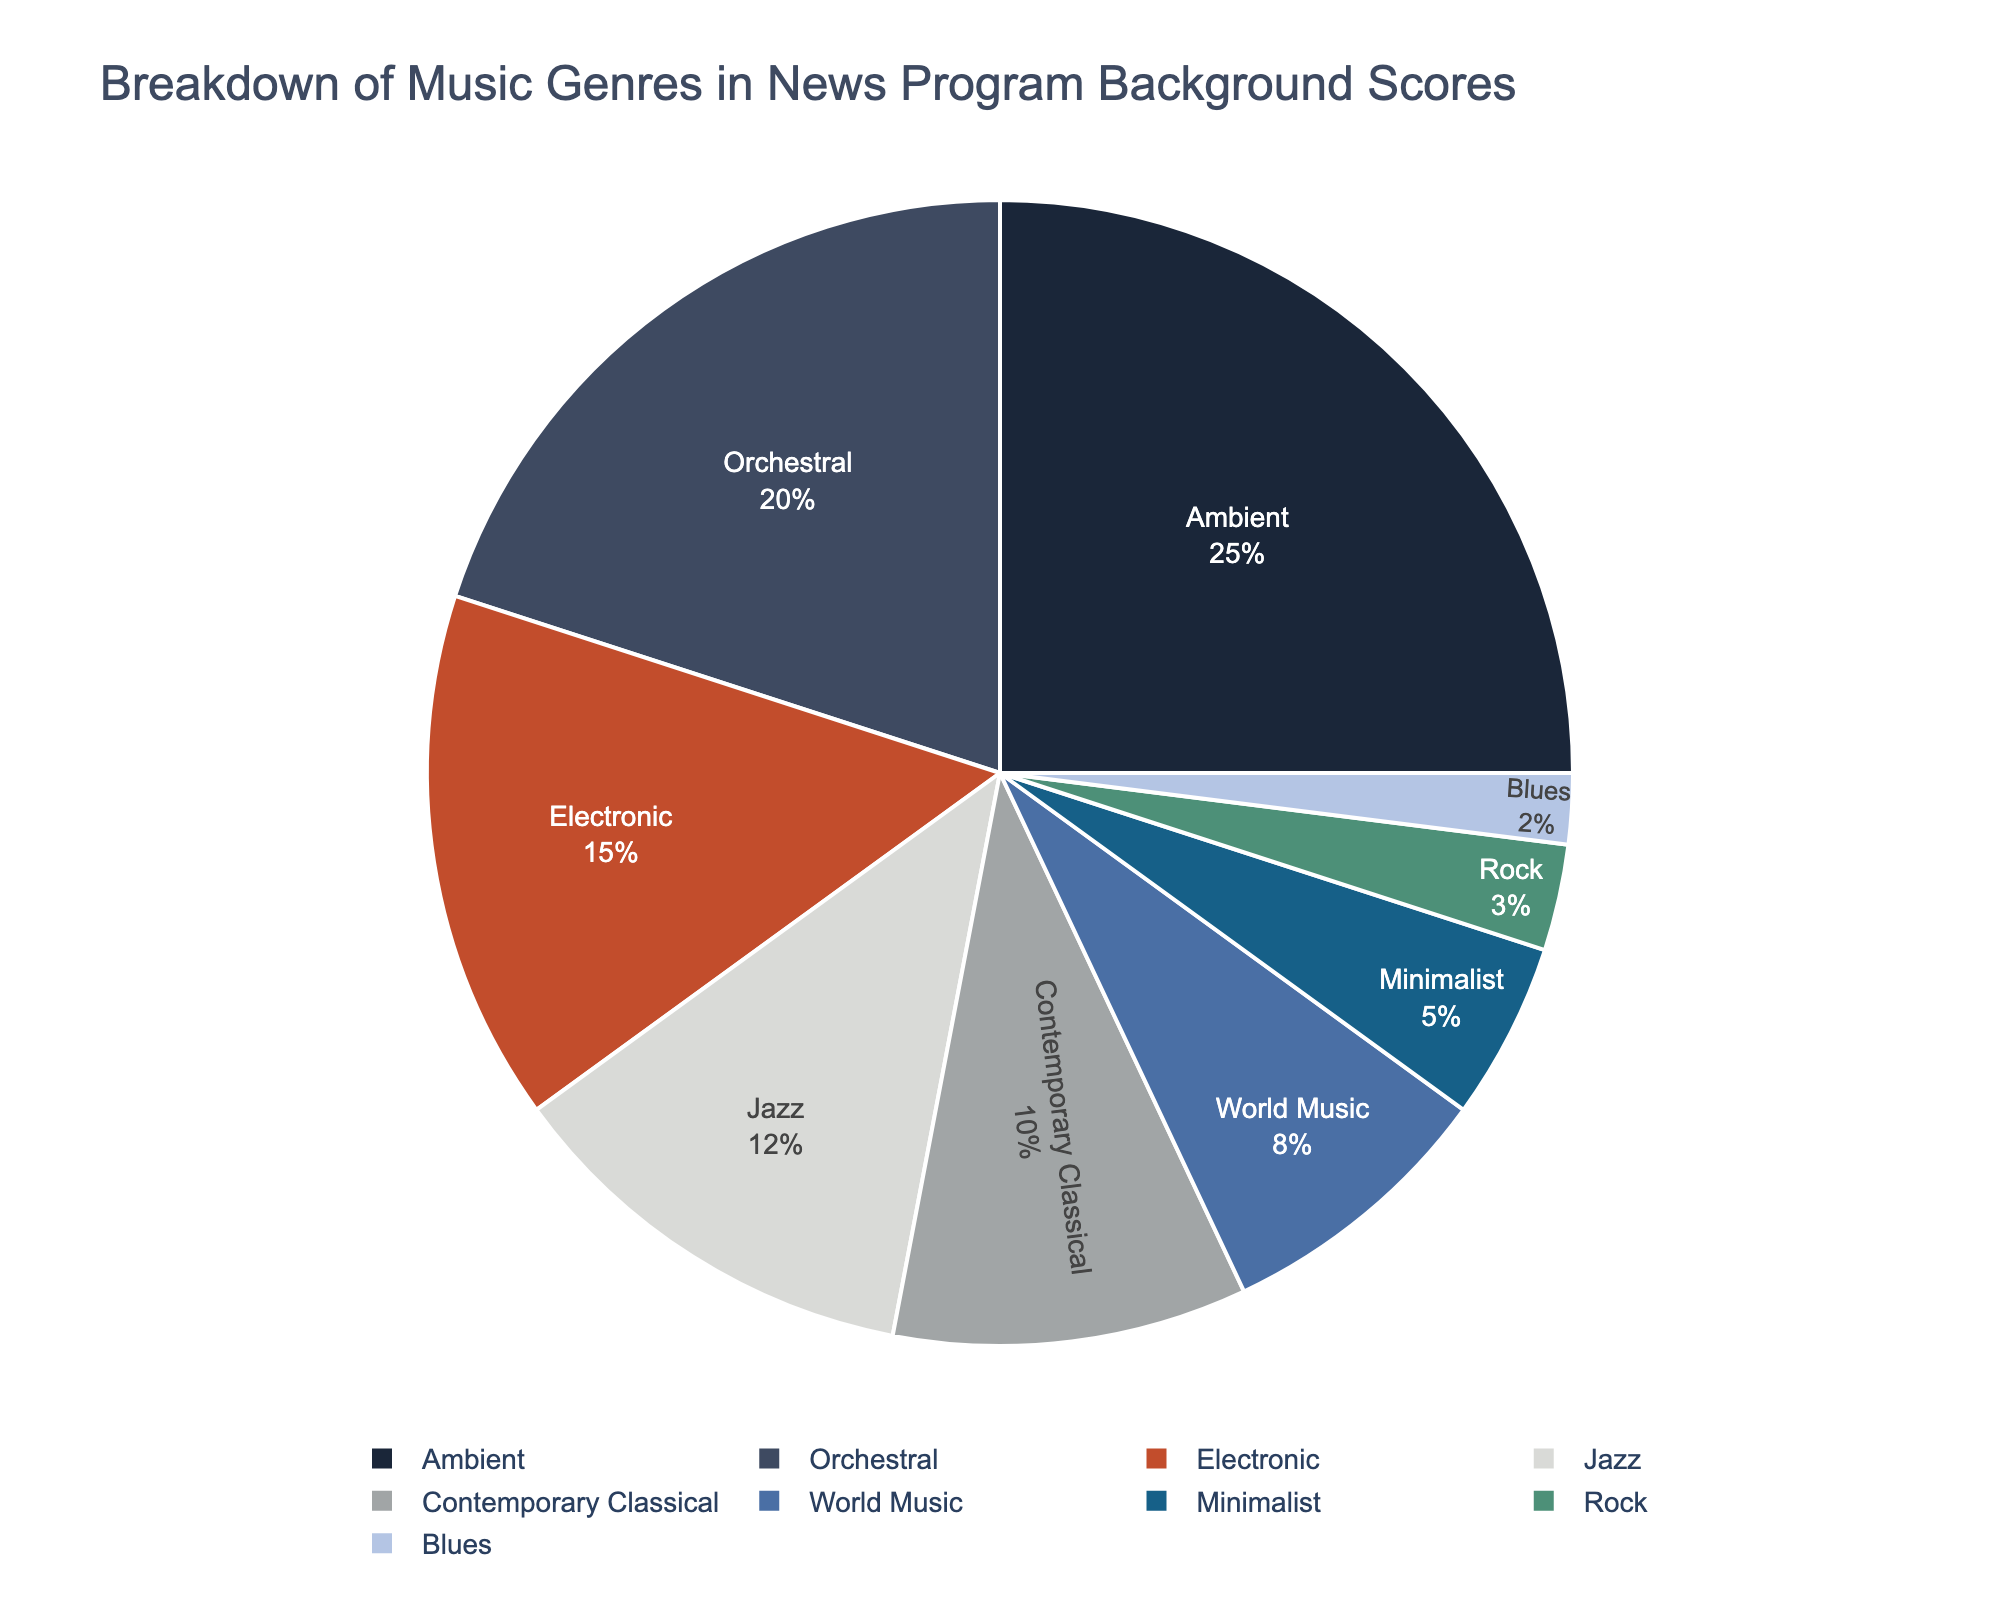What's the most frequently used music genre in news program background scores? By looking at the pie chart, the largest section represents the most frequently used genre for background scores. The largest section is for "Ambient" music.
Answer: Ambient Which music genre is used the least in news program background scores? The smallest section of the pie chart represents the least used genre. The smallest section is for "Blues" music.
Answer: Blues By how much does the usage of Ambient music exceed Orchestral music in news program background scores? From the pie chart, Ambient music accounts for 25%, and Orchestral music accounts for 20%. The difference is 25% - 20% = 5%.
Answer: 5% Which two music genres combined make up the highest percentage of background scores? Adding up the largest percentages, 'Ambient' (25%) and 'Orchestral' (20%) gives a combined total of 45%. This is the highest combination.
Answer: Ambient and Orchestral What are the three least used music genres in news program background scores? From the pie chart, the three smallest sections represent the least used genres. These are "Blues" (2%), "Rock" (3%), and "Minimalist" (5%).
Answer: Blues, Rock, and Minimalist Is the usage of Electronic music greater than the combined usage of Contemporary Classical and World Music? Electronic music accounts for 15%, Contemporary Classical for 10%, and World Music for 8%. The combined usage of Contemporary Classical and World Music is 10% + 8% = 18%. Since 18% is greater than 15%, Electronic music is less used.
Answer: No How much more is the combined percentage of genres Ambient, Orchestral, and Electronic compared to Jazz and Blues combined? Ambient (25%), Orchestral (20%), and Electronic (15%) combined is 25% + 20% + 15% = 60%. Jazz (12%) and Blues (2%) combined is 12% + 2% = 14%. The difference is 60% - 14% = 46%.
Answer: 46% Which genre has a percentage that is exactly double of Minimalist's percentage? Minimalist accounts for 5%. Double of 5% is 10%. Contemporary Classical, which is 10%, matches this.
Answer: Contemporary Classical Are the combined percentages of Orchestral and Contemporary Classical music higher than 30%? Orchestral is 20%, and Contemporary Classical is 10%. Together, they make up 20% + 10% = 30%. Since they exactly equal 30%, they are not higher but equal.
Answer: No Which genre slice in the pie chart is directly opposite the Ambient slice when viewed in the diagram? This would depend on the specific layout and orientation of the pie chart. Typically, opposite slices would be those at roughly 180 degrees from each other. Since specific slice placement is not provided, this cannot be definitively answered without the visual.
Answer: N/A 